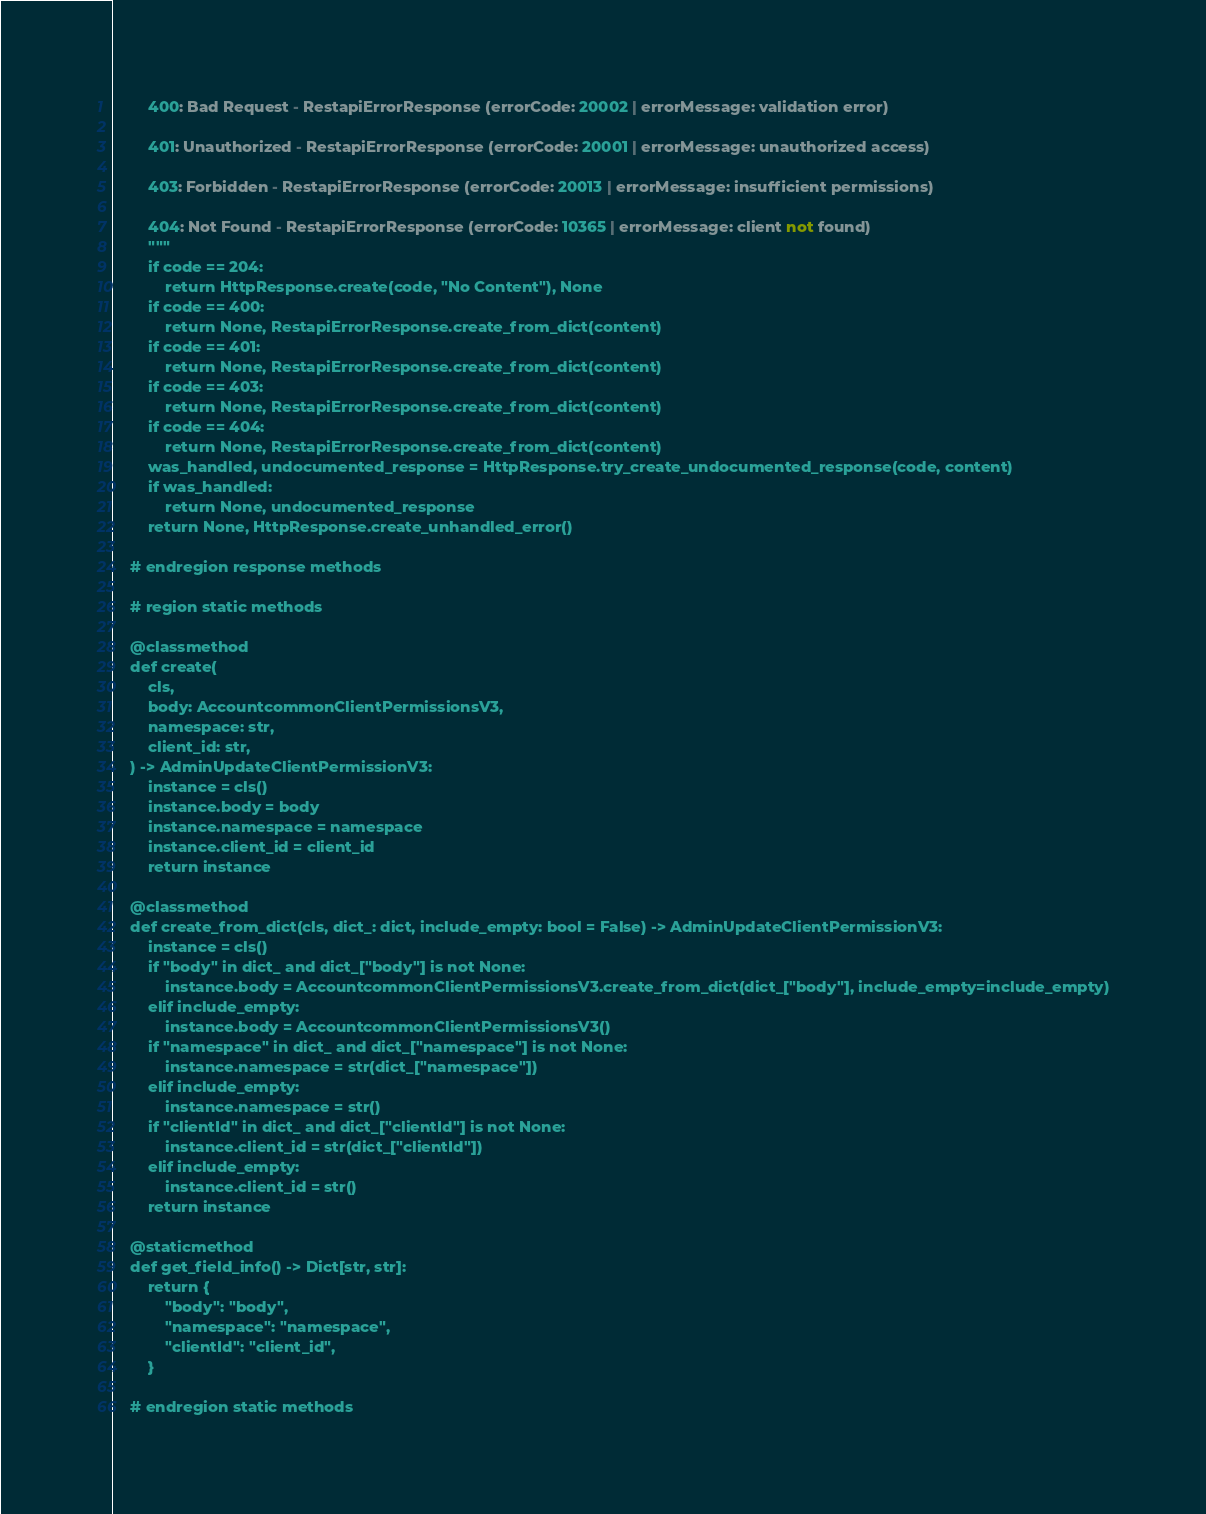Convert code to text. <code><loc_0><loc_0><loc_500><loc_500><_Python_>
        400: Bad Request - RestapiErrorResponse (errorCode: 20002 | errorMessage: validation error)

        401: Unauthorized - RestapiErrorResponse (errorCode: 20001 | errorMessage: unauthorized access)

        403: Forbidden - RestapiErrorResponse (errorCode: 20013 | errorMessage: insufficient permissions)

        404: Not Found - RestapiErrorResponse (errorCode: 10365 | errorMessage: client not found)
        """
        if code == 204:
            return HttpResponse.create(code, "No Content"), None
        if code == 400:
            return None, RestapiErrorResponse.create_from_dict(content)
        if code == 401:
            return None, RestapiErrorResponse.create_from_dict(content)
        if code == 403:
            return None, RestapiErrorResponse.create_from_dict(content)
        if code == 404:
            return None, RestapiErrorResponse.create_from_dict(content)
        was_handled, undocumented_response = HttpResponse.try_create_undocumented_response(code, content)
        if was_handled:
            return None, undocumented_response
        return None, HttpResponse.create_unhandled_error()

    # endregion response methods

    # region static methods

    @classmethod
    def create(
        cls,
        body: AccountcommonClientPermissionsV3,
        namespace: str,
        client_id: str,
    ) -> AdminUpdateClientPermissionV3:
        instance = cls()
        instance.body = body
        instance.namespace = namespace
        instance.client_id = client_id
        return instance

    @classmethod
    def create_from_dict(cls, dict_: dict, include_empty: bool = False) -> AdminUpdateClientPermissionV3:
        instance = cls()
        if "body" in dict_ and dict_["body"] is not None:
            instance.body = AccountcommonClientPermissionsV3.create_from_dict(dict_["body"], include_empty=include_empty)
        elif include_empty:
            instance.body = AccountcommonClientPermissionsV3()
        if "namespace" in dict_ and dict_["namespace"] is not None:
            instance.namespace = str(dict_["namespace"])
        elif include_empty:
            instance.namespace = str()
        if "clientId" in dict_ and dict_["clientId"] is not None:
            instance.client_id = str(dict_["clientId"])
        elif include_empty:
            instance.client_id = str()
        return instance

    @staticmethod
    def get_field_info() -> Dict[str, str]:
        return {
            "body": "body",
            "namespace": "namespace",
            "clientId": "client_id",
        }

    # endregion static methods
</code> 